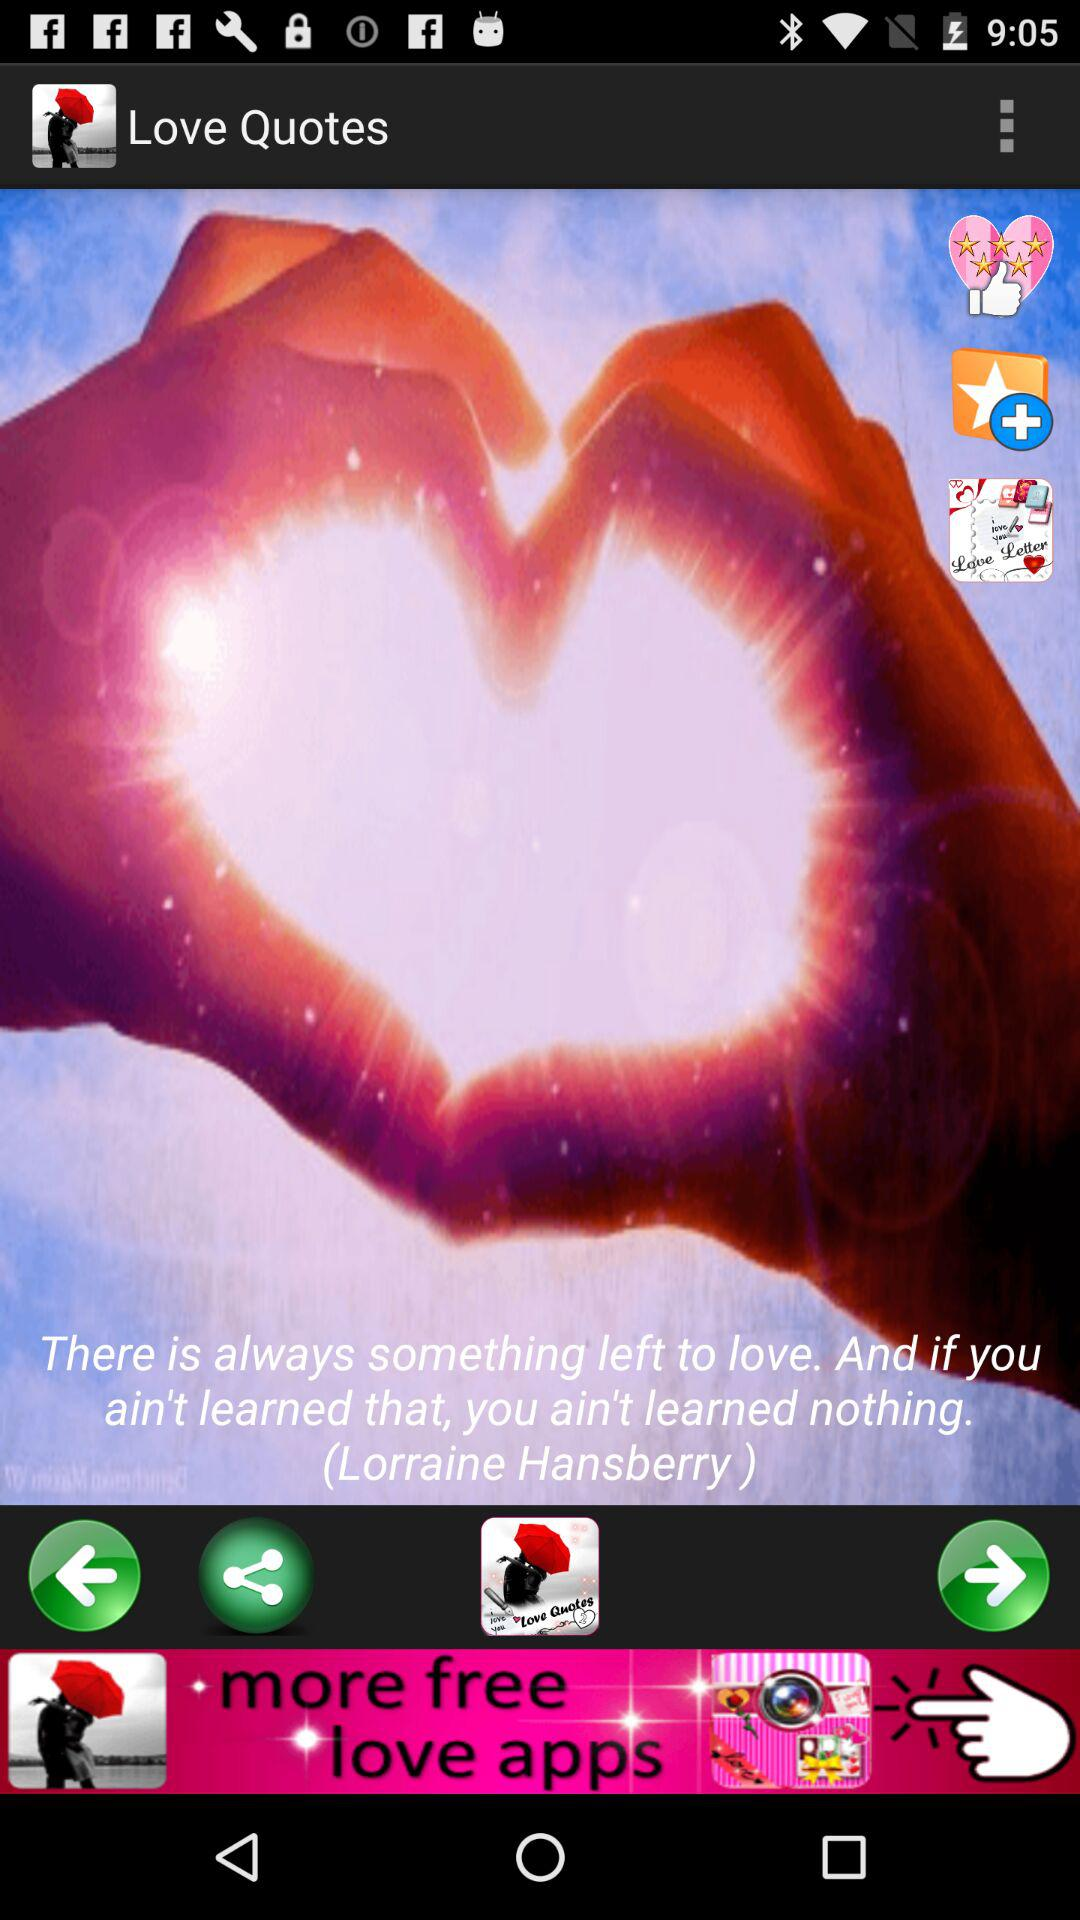What is the name of the application? The name of the application is "Love Quotes". 